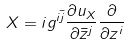<formula> <loc_0><loc_0><loc_500><loc_500>X = i g ^ { i \bar { j } } \frac { \partial u _ { X } } { \partial \bar { z } ^ { j } } \frac { \partial } { \partial z ^ { i } }</formula> 